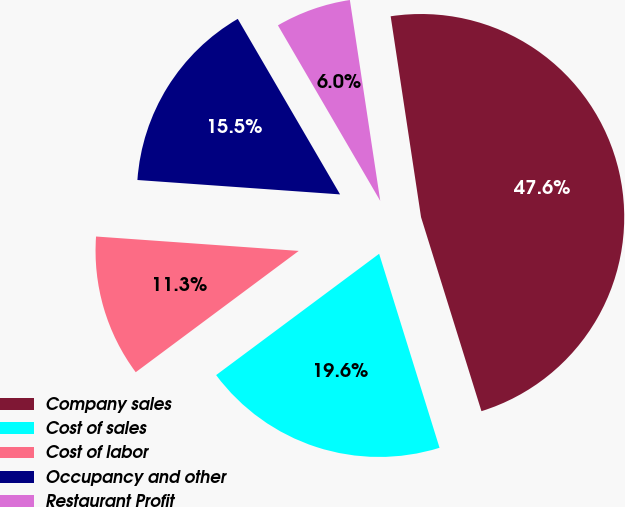Convert chart. <chart><loc_0><loc_0><loc_500><loc_500><pie_chart><fcel>Company sales<fcel>Cost of sales<fcel>Cost of labor<fcel>Occupancy and other<fcel>Restaurant Profit<nl><fcel>47.58%<fcel>19.62%<fcel>11.31%<fcel>15.47%<fcel>6.01%<nl></chart> 